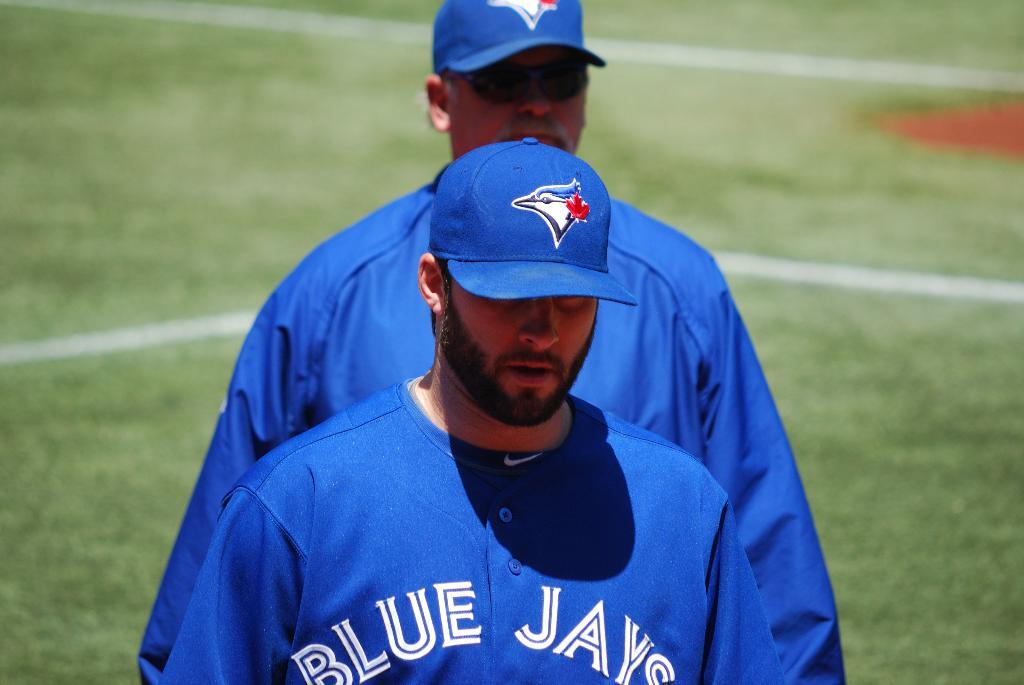<image>
Give a short and clear explanation of the subsequent image. Baseball players wearing blue uniforms with Blue Jay on the front. 